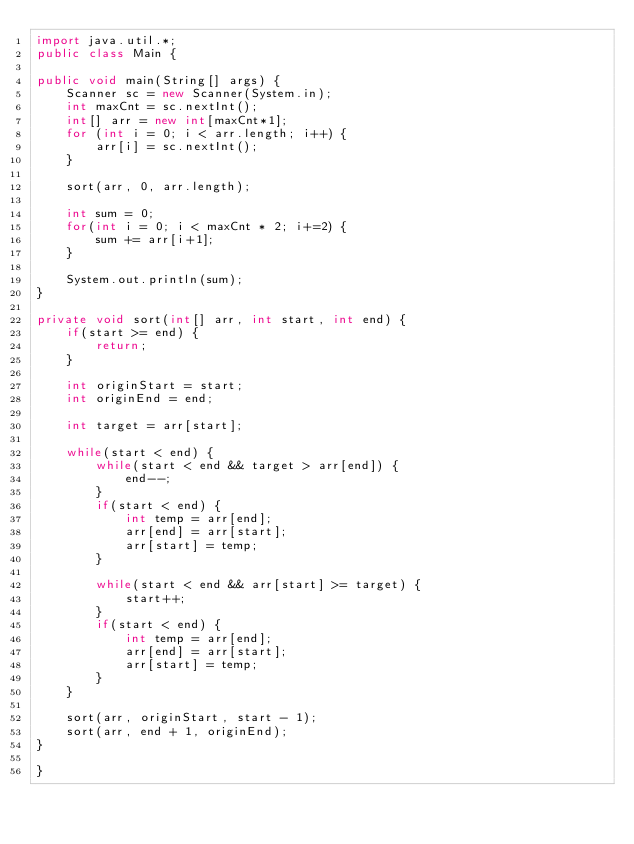Convert code to text. <code><loc_0><loc_0><loc_500><loc_500><_Java_>import java.util.*;
public class Main {

public void main(String[] args) {
	Scanner sc = new Scanner(System.in);
	int maxCnt = sc.nextInt();
	int[] arr = new int[maxCnt*1];
	for (int i = 0; i < arr.length; i++) {
		arr[i] = sc.nextInt();
	}

	sort(arr, 0, arr.length);

	int sum = 0;
	for(int i = 0; i < maxCnt * 2; i+=2) {
		sum += arr[i+1];
	} 

	System.out.println(sum);
}

private void sort(int[] arr, int start, int end) {
	if(start >= end) {
		return;
	}

	int originStart = start;
	int originEnd = end;

	int target = arr[start];

	while(start < end) {
		while(start < end && target > arr[end]) {
			end--;
		}
		if(start < end) {
			int temp = arr[end];
			arr[end] = arr[start];
			arr[start] = temp;
		}

		while(start < end && arr[start] >= target) {
			start++;
		}
		if(start < end) {
			int temp = arr[end];
			arr[end] = arr[start];
			arr[start] = temp;
		}
	}

	sort(arr, originStart, start - 1);
	sort(arr, end + 1, originEnd);
}

}
</code> 